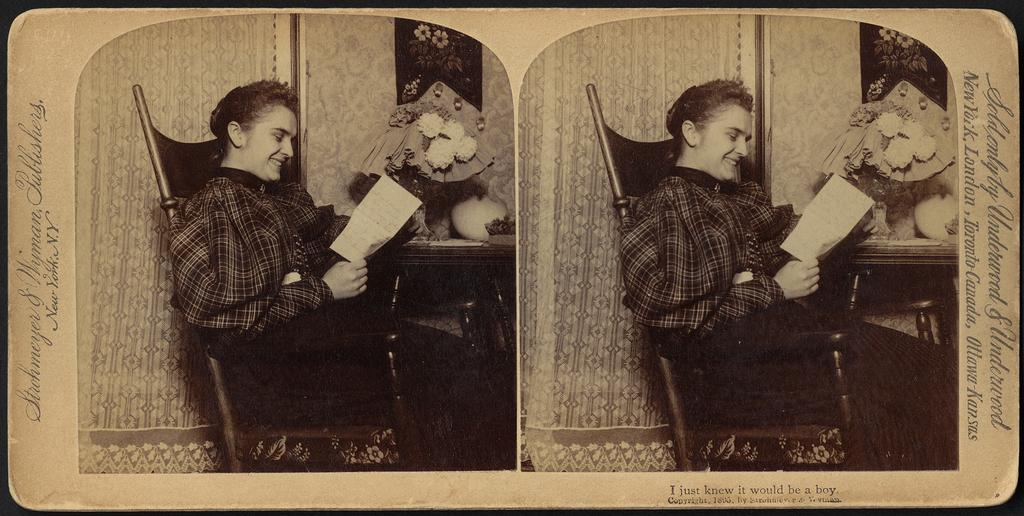Who is the main subject in the image? There is a woman in the image. What is the woman doing in the image? The woman is sitting in a chair. What is the woman holding in her hand? The woman is holding a paper in her hand. What can be seen in the background of the image? There are flowers in the background of the image. Where are the flowers placed in the image? The flowers are placed on a table. What type of comb is the woman using on her hair in the image? There is no comb visible in the image, and the woman's hair is not being styled or groomed. 